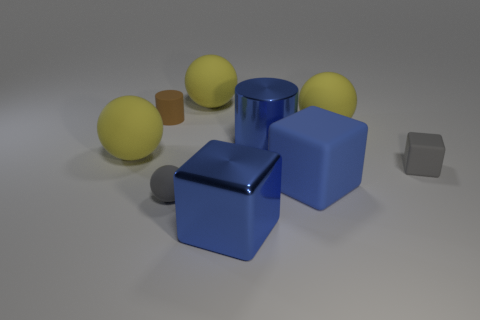Subtract all yellow blocks. How many yellow balls are left? 3 Subtract all cylinders. How many objects are left? 7 Add 1 tiny gray balls. How many objects exist? 10 Subtract all large yellow balls. Subtract all blue shiny cylinders. How many objects are left? 5 Add 1 gray matte blocks. How many gray matte blocks are left? 2 Add 5 tiny green rubber cylinders. How many tiny green rubber cylinders exist? 5 Subtract 2 blue blocks. How many objects are left? 7 